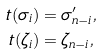<formula> <loc_0><loc_0><loc_500><loc_500>t ( \sigma _ { i } ) & = \sigma ^ { \prime } _ { n - i } , \\ t ( \zeta _ { i } ) & = \zeta _ { n - i } ,</formula> 